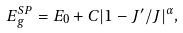<formula> <loc_0><loc_0><loc_500><loc_500>E _ { g } ^ { S P } = E _ { 0 } + C | 1 - J ^ { \prime } / J | ^ { \alpha } ,</formula> 